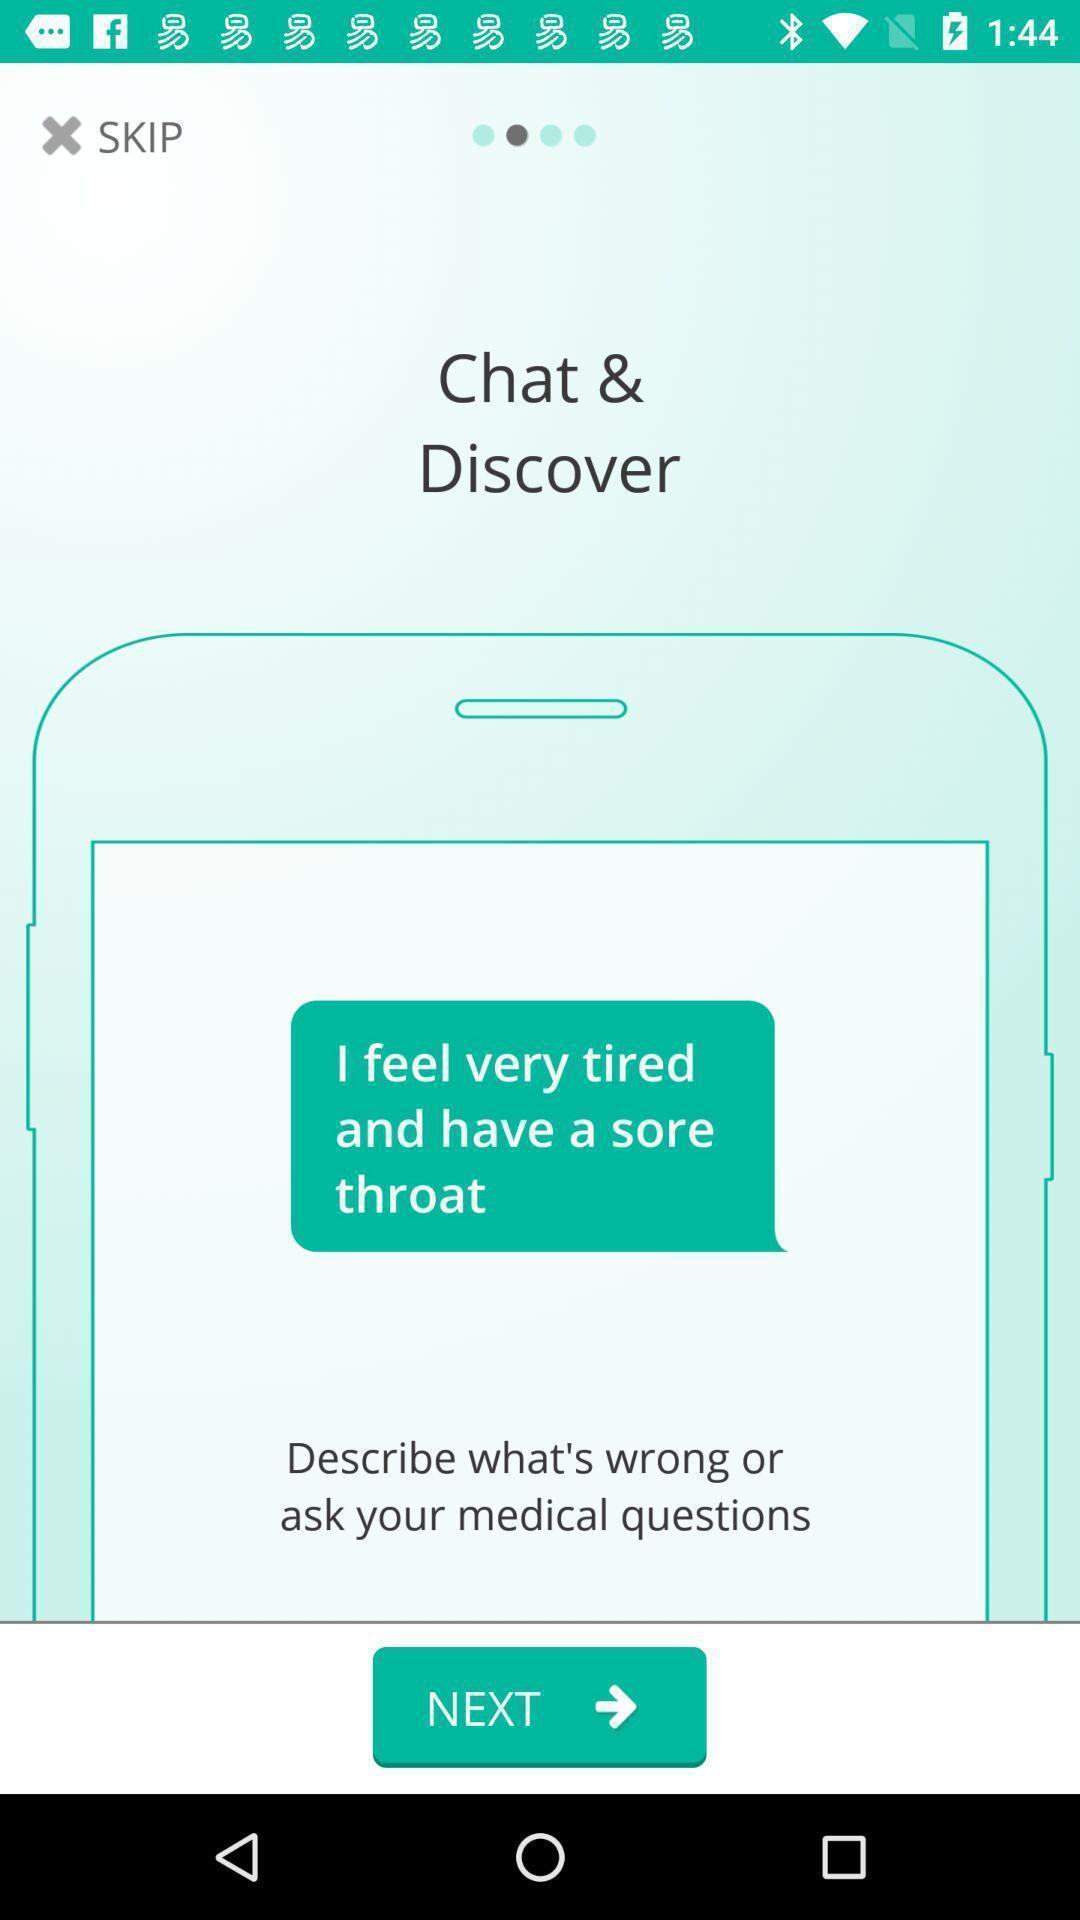Tell me what you see in this picture. Welcome page. 